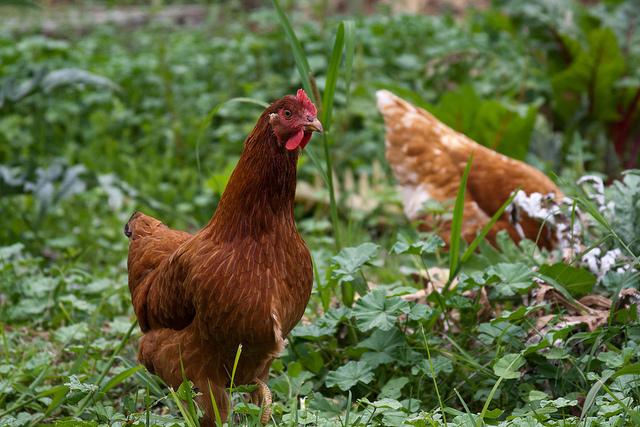Is the chicken looking at the camera?
Short answer required. No. Are the animals inside?
Short answer required. No. How many chickens?
Concise answer only. 2. Could the fowl closest to the viewer lay an egg?
Be succinct. Yes. What sex is this bird?
Answer briefly. Female. 